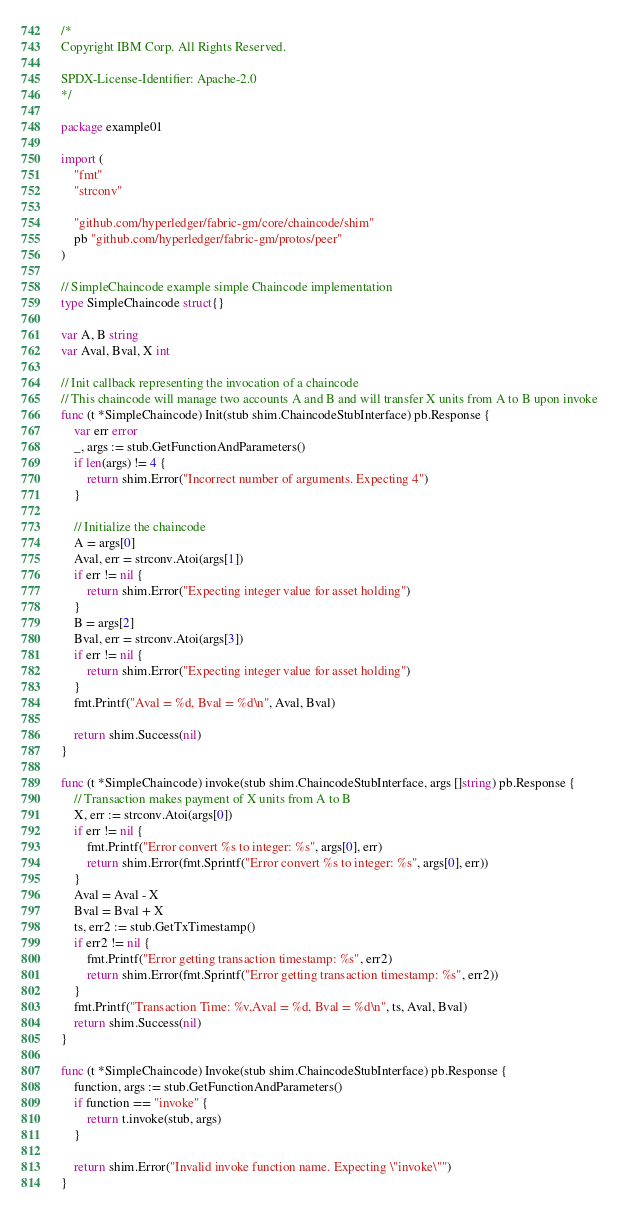<code> <loc_0><loc_0><loc_500><loc_500><_Go_>/*
Copyright IBM Corp. All Rights Reserved.

SPDX-License-Identifier: Apache-2.0
*/

package example01

import (
	"fmt"
	"strconv"

	"github.com/hyperledger/fabric-gm/core/chaincode/shim"
	pb "github.com/hyperledger/fabric-gm/protos/peer"
)

// SimpleChaincode example simple Chaincode implementation
type SimpleChaincode struct{}

var A, B string
var Aval, Bval, X int

// Init callback representing the invocation of a chaincode
// This chaincode will manage two accounts A and B and will transfer X units from A to B upon invoke
func (t *SimpleChaincode) Init(stub shim.ChaincodeStubInterface) pb.Response {
	var err error
	_, args := stub.GetFunctionAndParameters()
	if len(args) != 4 {
		return shim.Error("Incorrect number of arguments. Expecting 4")
	}

	// Initialize the chaincode
	A = args[0]
	Aval, err = strconv.Atoi(args[1])
	if err != nil {
		return shim.Error("Expecting integer value for asset holding")
	}
	B = args[2]
	Bval, err = strconv.Atoi(args[3])
	if err != nil {
		return shim.Error("Expecting integer value for asset holding")
	}
	fmt.Printf("Aval = %d, Bval = %d\n", Aval, Bval)

	return shim.Success(nil)
}

func (t *SimpleChaincode) invoke(stub shim.ChaincodeStubInterface, args []string) pb.Response {
	// Transaction makes payment of X units from A to B
	X, err := strconv.Atoi(args[0])
	if err != nil {
		fmt.Printf("Error convert %s to integer: %s", args[0], err)
		return shim.Error(fmt.Sprintf("Error convert %s to integer: %s", args[0], err))
	}
	Aval = Aval - X
	Bval = Bval + X
	ts, err2 := stub.GetTxTimestamp()
	if err2 != nil {
		fmt.Printf("Error getting transaction timestamp: %s", err2)
		return shim.Error(fmt.Sprintf("Error getting transaction timestamp: %s", err2))
	}
	fmt.Printf("Transaction Time: %v,Aval = %d, Bval = %d\n", ts, Aval, Bval)
	return shim.Success(nil)
}

func (t *SimpleChaincode) Invoke(stub shim.ChaincodeStubInterface) pb.Response {
	function, args := stub.GetFunctionAndParameters()
	if function == "invoke" {
		return t.invoke(stub, args)
	}

	return shim.Error("Invalid invoke function name. Expecting \"invoke\"")
}
</code> 